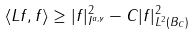<formula> <loc_0><loc_0><loc_500><loc_500>\langle L f , f \rangle \geq | f | ^ { 2 } _ { I ^ { a , \gamma } } - C | f | ^ { 2 } _ { L ^ { 2 } ( B _ { C } ) }</formula> 